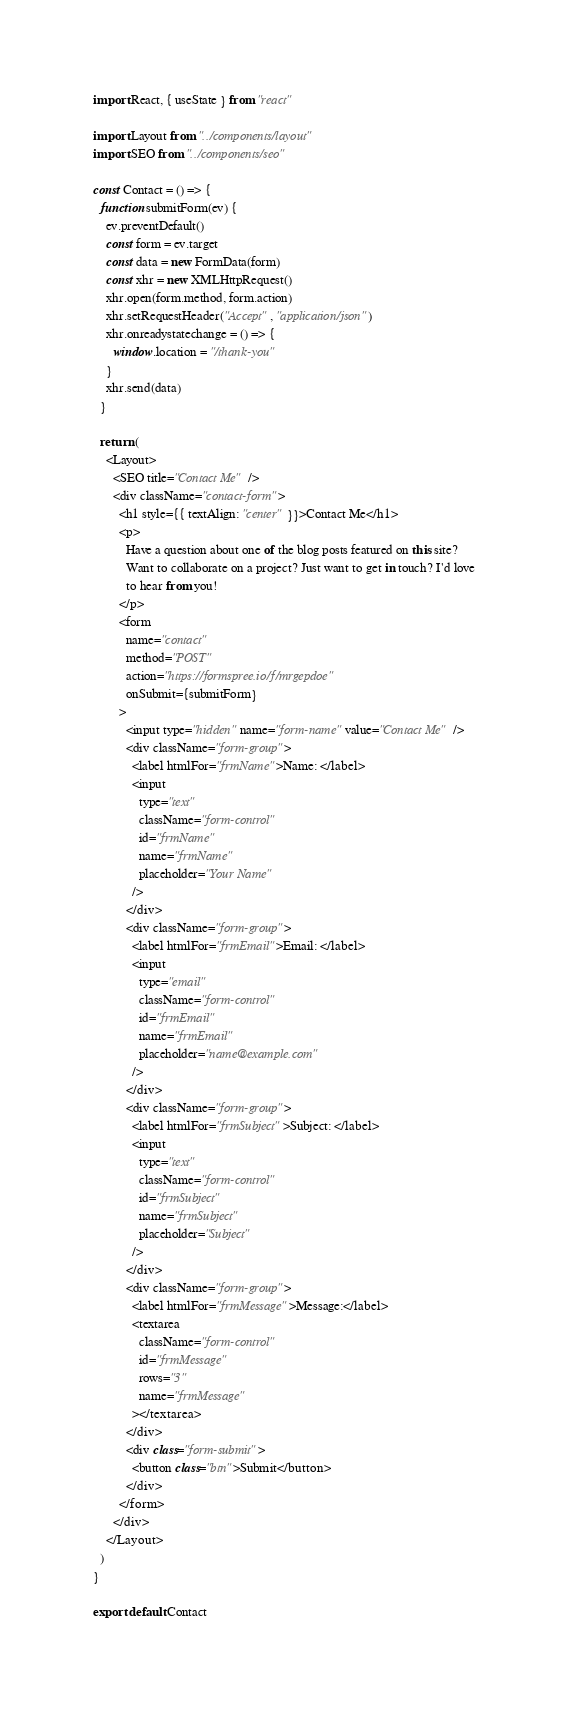<code> <loc_0><loc_0><loc_500><loc_500><_JavaScript_>import React, { useState } from "react"

import Layout from "../components/layout"
import SEO from "../components/seo"

const Contact = () => {
  function submitForm(ev) {
    ev.preventDefault()
    const form = ev.target
    const data = new FormData(form)
    const xhr = new XMLHttpRequest()
    xhr.open(form.method, form.action)
    xhr.setRequestHeader("Accept", "application/json")
    xhr.onreadystatechange = () => {
      window.location = "/thank-you"
    }
    xhr.send(data)
  }

  return (
    <Layout>
      <SEO title="Contact Me" />
      <div className="contact-form">
        <h1 style={{ textAlign: "center" }}>Contact Me</h1>
        <p>
          Have a question about one of the blog posts featured on this site?
          Want to collaborate on a project? Just want to get in touch? I'd love
          to hear from you!
        </p>
        <form
          name="contact"
          method="POST"
          action="https://formspree.io/f/mrgepdoe"
          onSubmit={submitForm}
        >
          <input type="hidden" name="form-name" value="Contact Me" />
          <div className="form-group">
            <label htmlFor="frmName">Name: </label>
            <input
              type="text"
              className="form-control"
              id="frmName"
              name="frmName"
              placeholder="Your Name"
            />
          </div>
          <div className="form-group">
            <label htmlFor="frmEmail">Email: </label>
            <input
              type="email"
              className="form-control"
              id="frmEmail"
              name="frmEmail"
              placeholder="name@example.com"
            />
          </div>
          <div className="form-group">
            <label htmlFor="frmSubject">Subject: </label>
            <input
              type="text"
              className="form-control"
              id="frmSubject"
              name="frmSubject"
              placeholder="Subject"
            />
          </div>
          <div className="form-group">
            <label htmlFor="frmMessage">Message:</label>
            <textarea
              className="form-control"
              id="frmMessage"
              rows="3"
              name="frmMessage"
            ></textarea>
          </div>
          <div class="form-submit">
            <button class="btn">Submit</button>
          </div>
        </form>
      </div>
    </Layout>
  )
}

export default Contact
</code> 